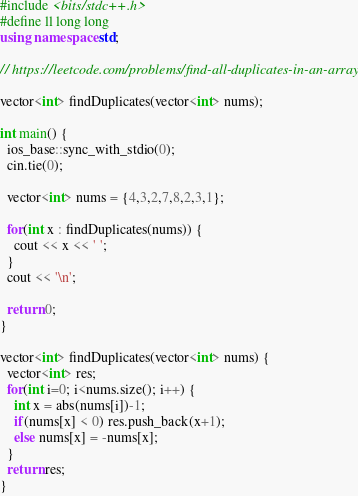Convert code to text. <code><loc_0><loc_0><loc_500><loc_500><_C++_>#include <bits/stdc++.h>
#define ll long long
using namespace std;

// https://leetcode.com/problems/find-all-duplicates-in-an-array/

vector<int> findDuplicates(vector<int> nums);

int main() {
  ios_base::sync_with_stdio(0);
  cin.tie(0);

  vector<int> nums = {4,3,2,7,8,2,3,1};

  for(int x : findDuplicates(nums)) {
    cout << x << ' ';
  }
  cout << '\n';
  
  return 0;
}

vector<int> findDuplicates(vector<int> nums) {
  vector<int> res;
  for(int i=0; i<nums.size(); i++) {
    int x = abs(nums[i])-1;
    if(nums[x] < 0) res.push_back(x+1);
    else nums[x] = -nums[x];
  }
  return res;
}</code> 